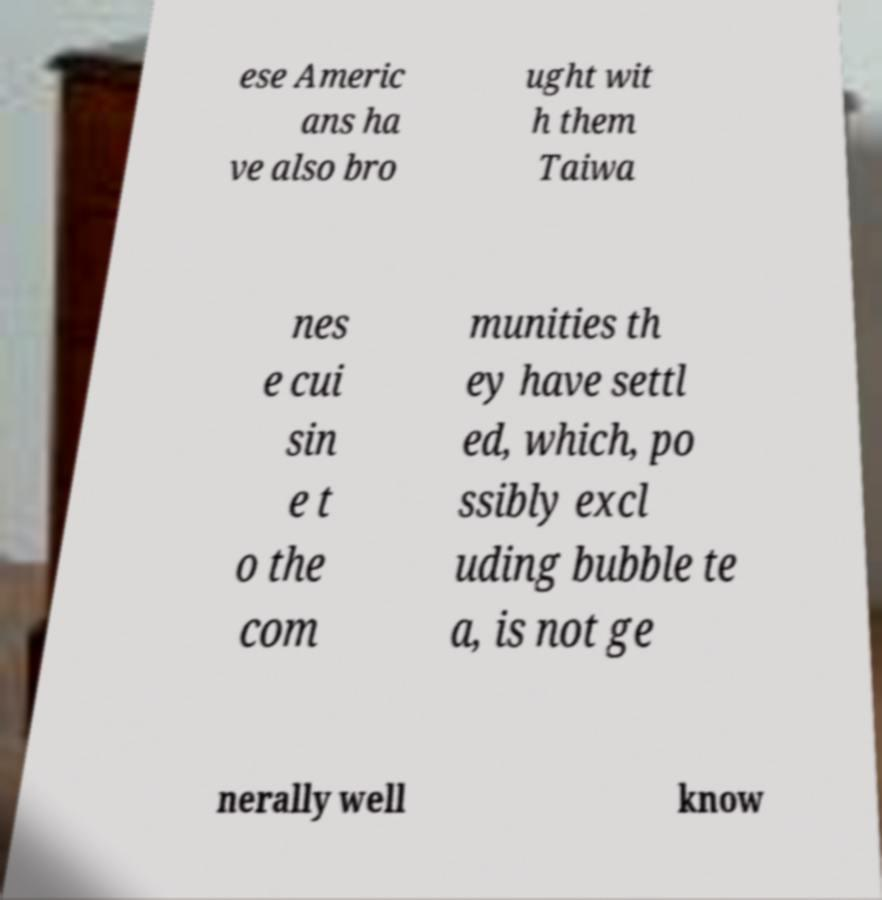Can you accurately transcribe the text from the provided image for me? ese Americ ans ha ve also bro ught wit h them Taiwa nes e cui sin e t o the com munities th ey have settl ed, which, po ssibly excl uding bubble te a, is not ge nerally well know 